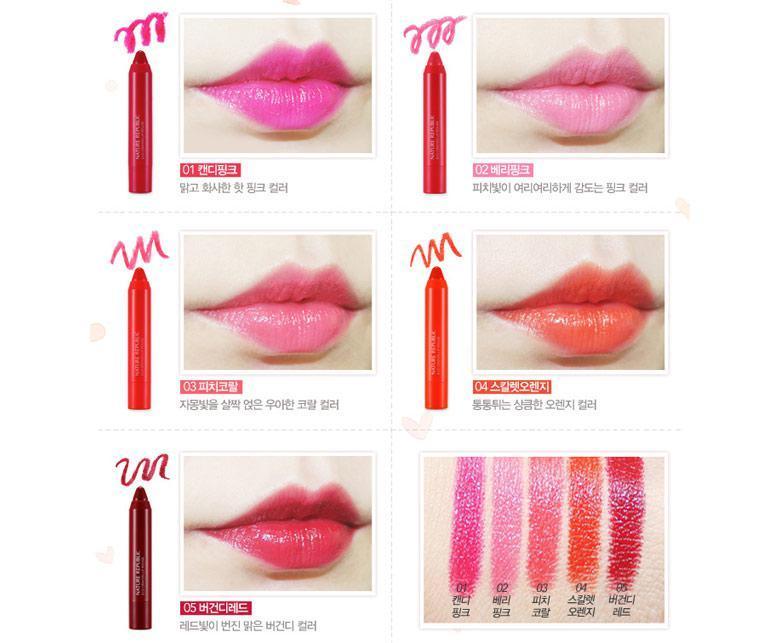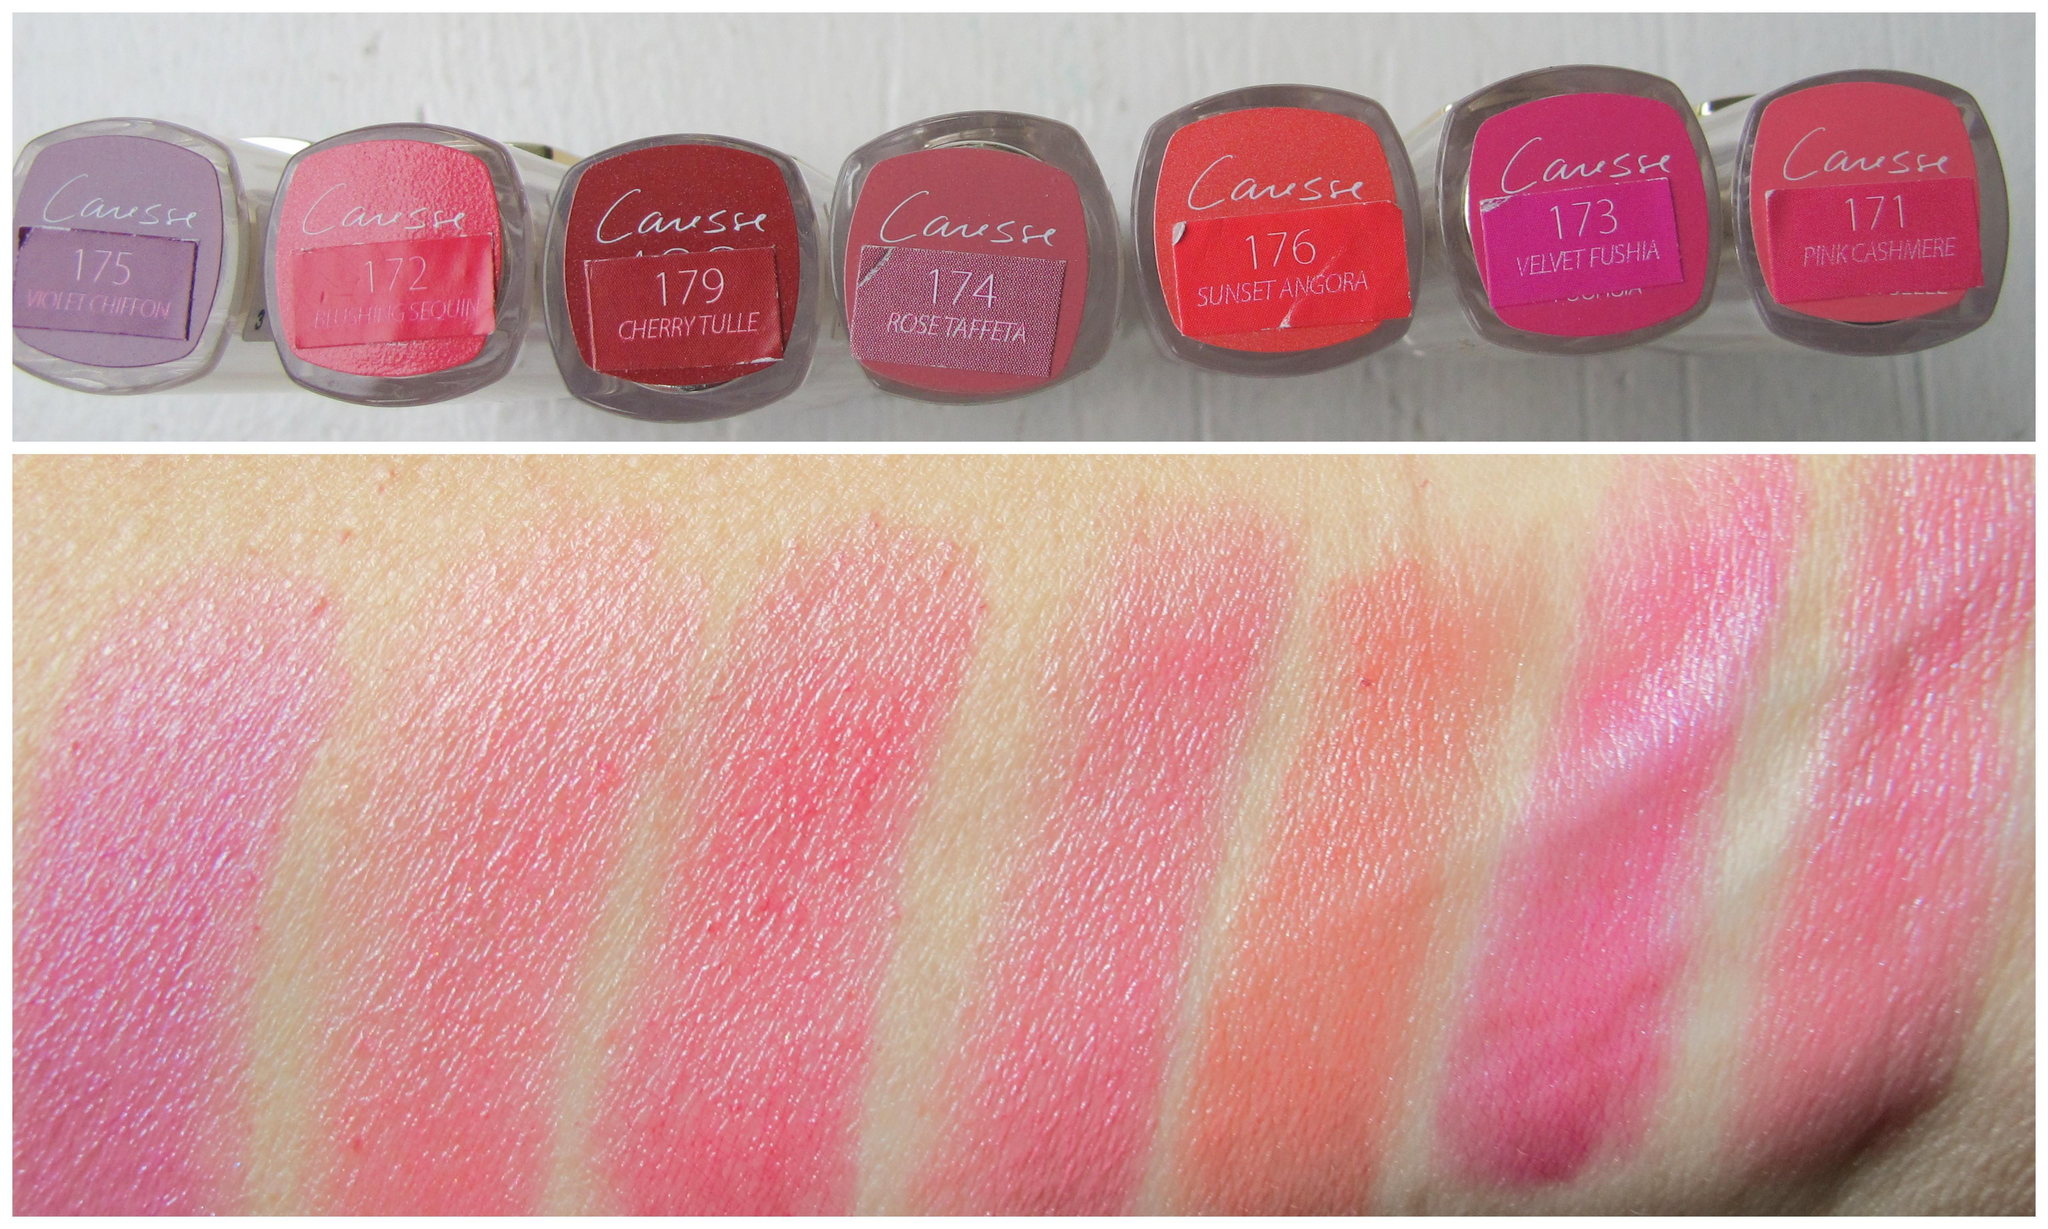The first image is the image on the left, the second image is the image on the right. Given the left and right images, does the statement "At least two pairs of lips are visible." hold true? Answer yes or no. Yes. The first image is the image on the left, the second image is the image on the right. Analyze the images presented: Is the assertion "There are lips in one of the images." valid? Answer yes or no. Yes. 